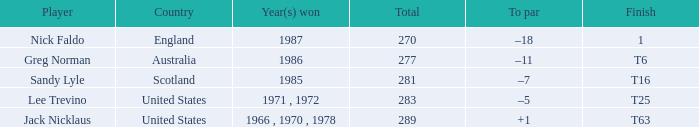What country has a total greater than 270, with sandy lyle as the player? Scotland. 